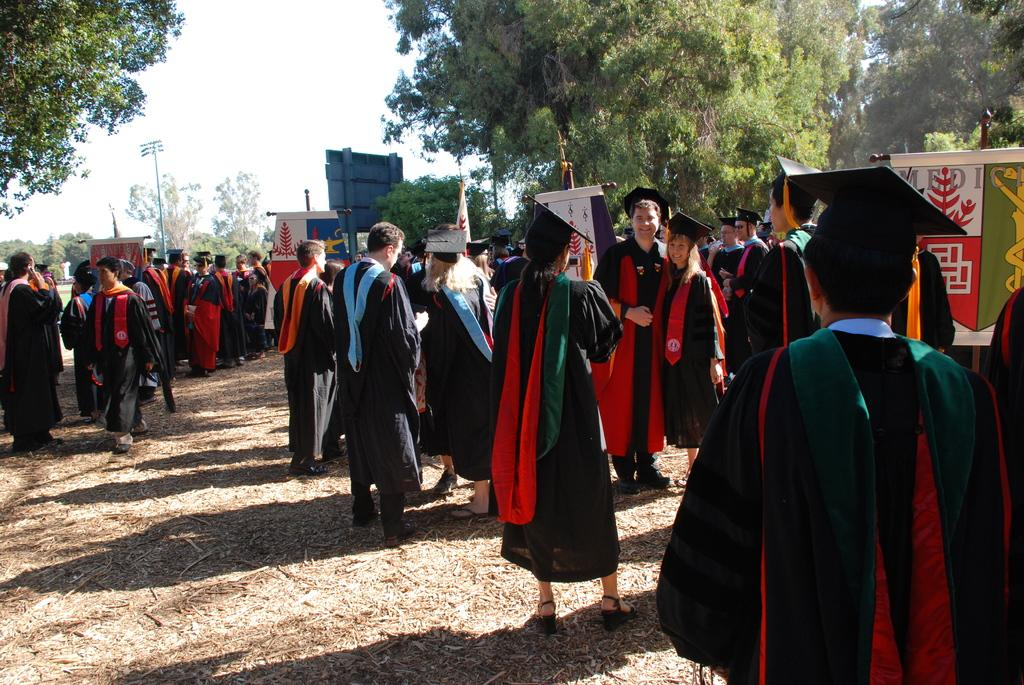Who is present in the image? There are girls and boys in the image. What are the individuals wearing? The girls and boys are wearing black color gowns. What is the purpose of the gowns? The gowns are for a convocation. Where are the individuals standing? They are standing on the ground. What are they doing? They are taking photographs. What can be seen in the background? There are trees visible in the background. What type of wine is being served at the convocation in the image? There is no mention of wine or any beverage being served in the image. The focus is on the individuals wearing gowns and taking photographs. 